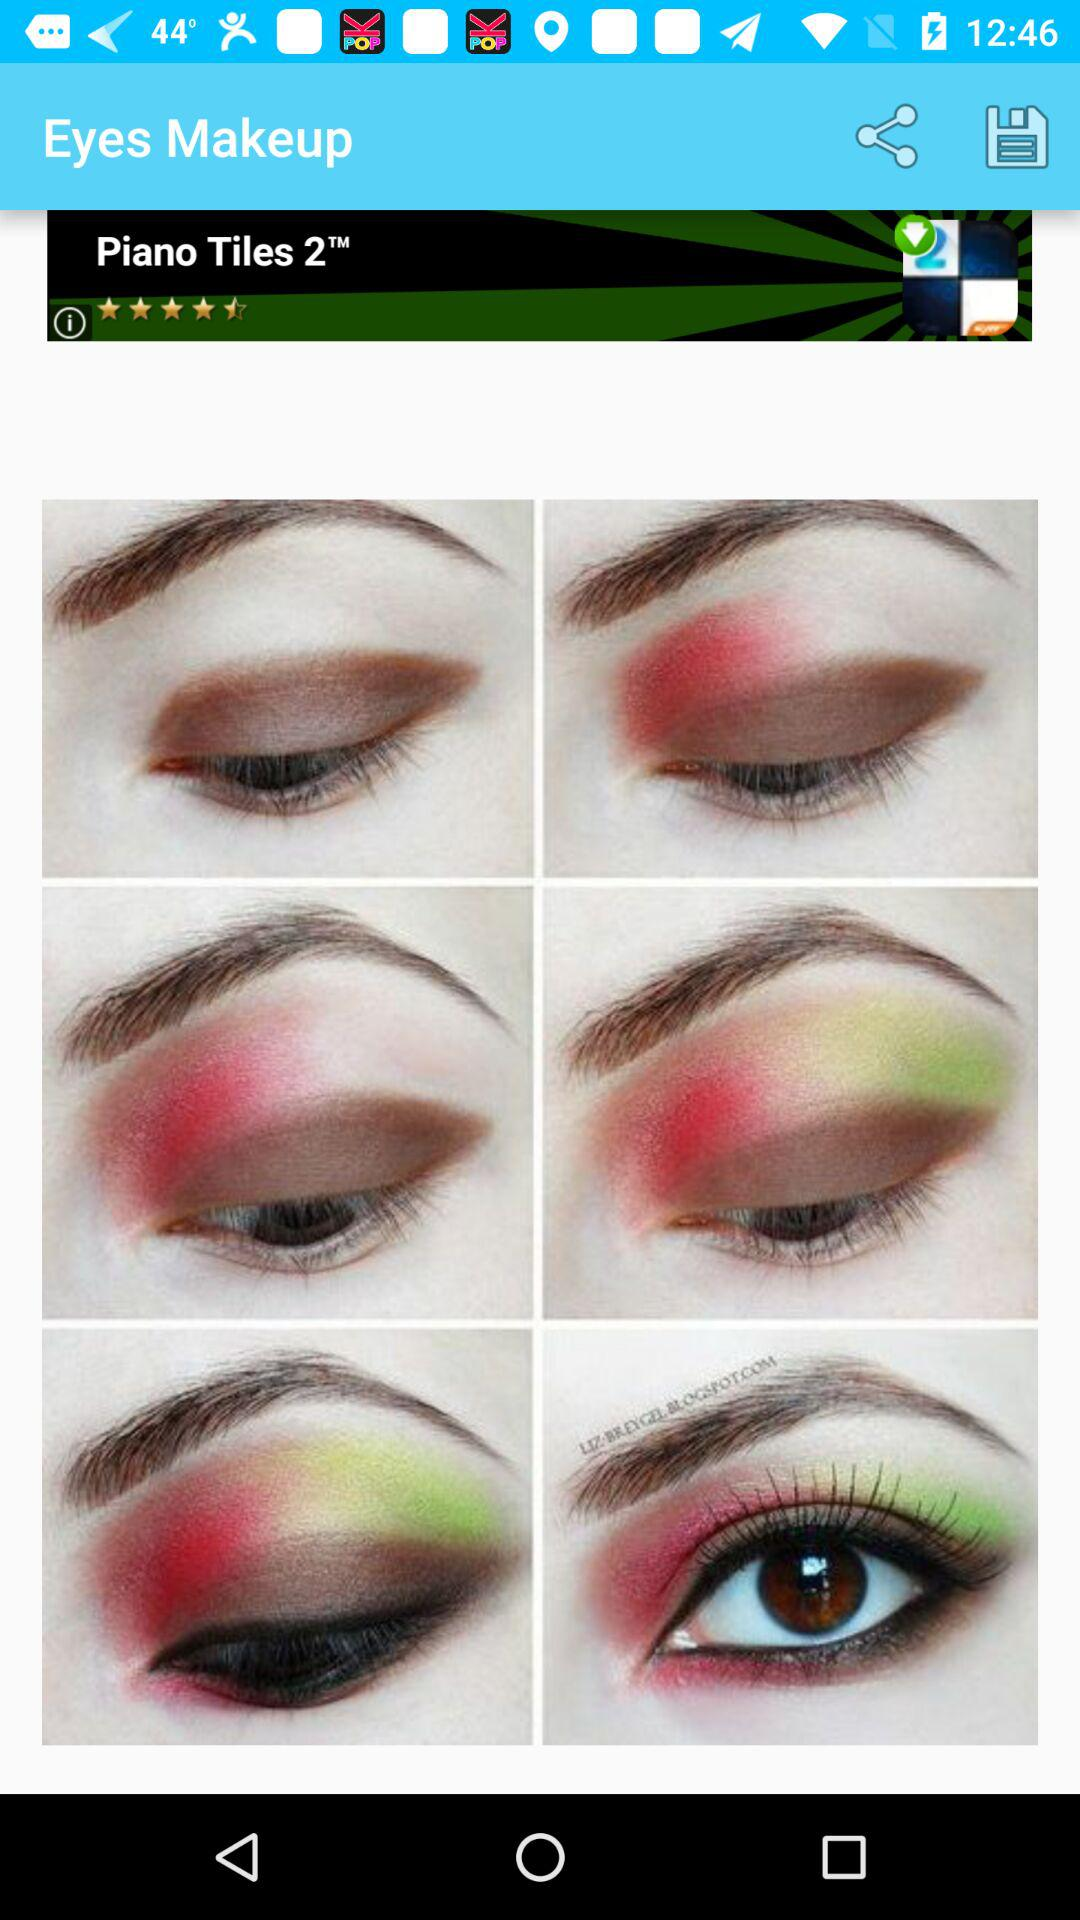What is the application name? The application name is "Eyes Makeup". 